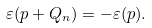<formula> <loc_0><loc_0><loc_500><loc_500>\varepsilon ( { p } + { Q } _ { n } ) = - \varepsilon ( { p } ) .</formula> 